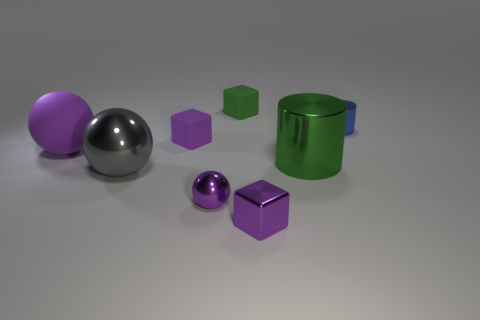Add 2 large red shiny cylinders. How many objects exist? 10 Subtract all cylinders. How many objects are left? 6 Add 7 small metallic cylinders. How many small metallic cylinders are left? 8 Add 3 gray matte cylinders. How many gray matte cylinders exist? 3 Subtract 1 green cylinders. How many objects are left? 7 Subtract all small gray spheres. Subtract all tiny blue shiny cylinders. How many objects are left? 7 